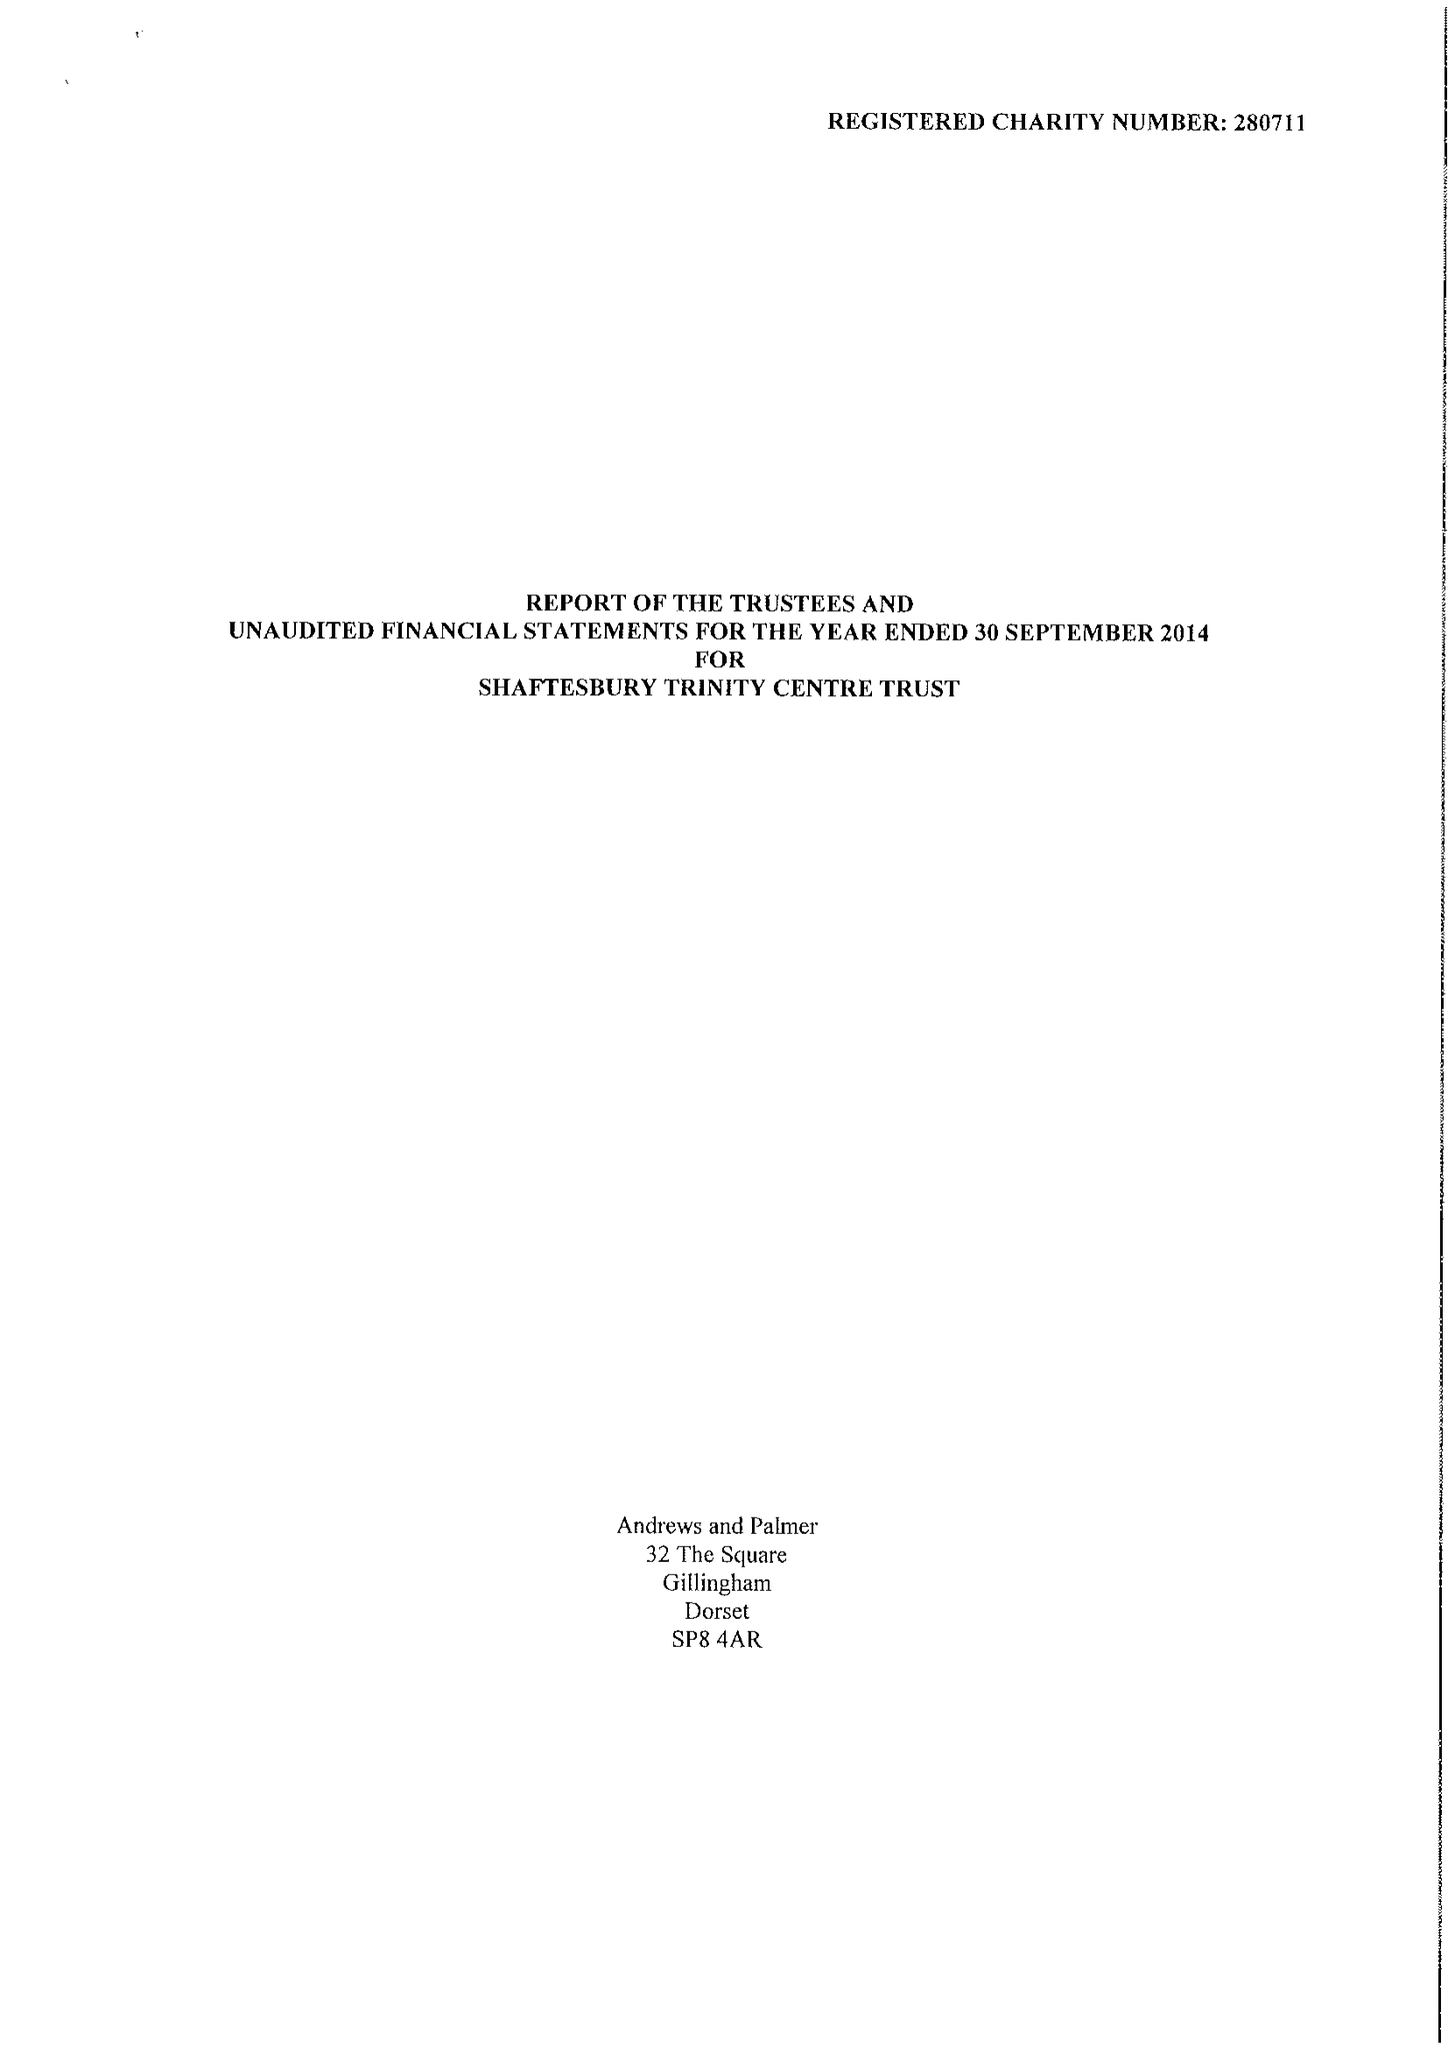What is the value for the address__postcode?
Answer the question using a single word or phrase. SP8 5JH 